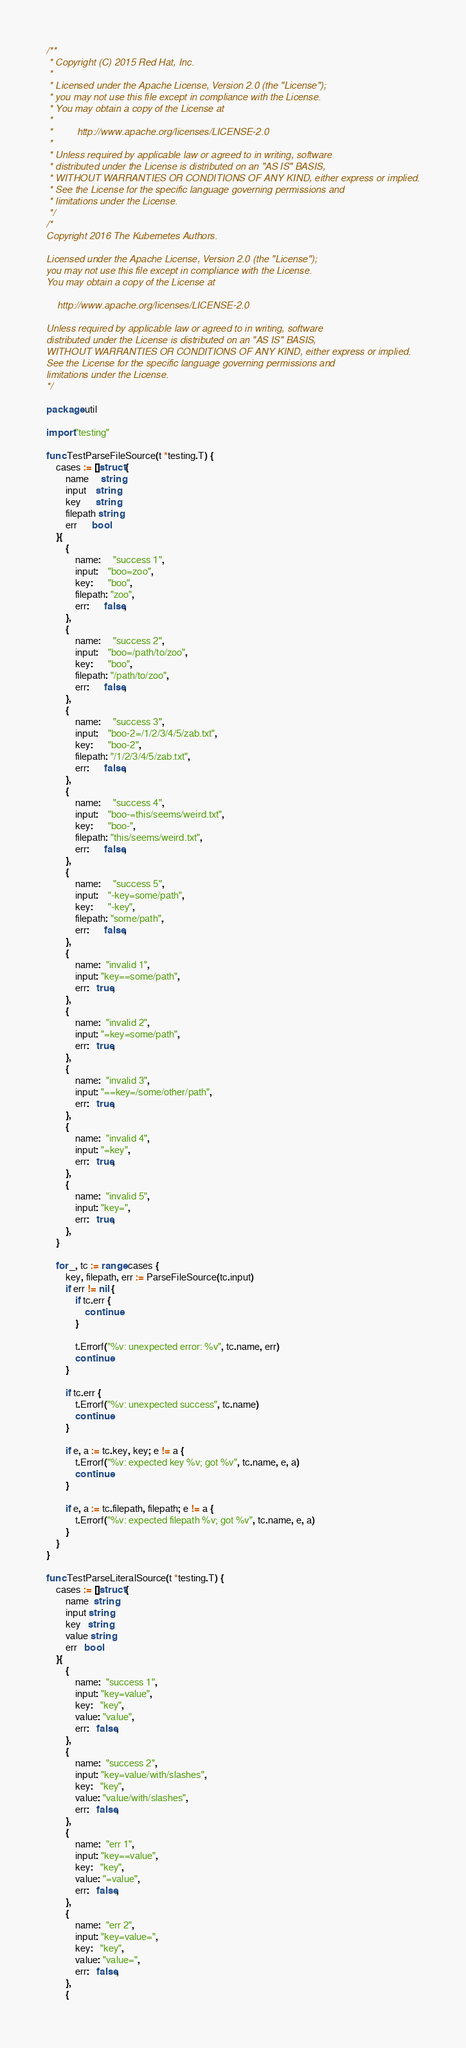Convert code to text. <code><loc_0><loc_0><loc_500><loc_500><_Go_>/**
 * Copyright (C) 2015 Red Hat, Inc.
 *
 * Licensed under the Apache License, Version 2.0 (the "License");
 * you may not use this file except in compliance with the License.
 * You may obtain a copy of the License at
 *
 *         http://www.apache.org/licenses/LICENSE-2.0
 *
 * Unless required by applicable law or agreed to in writing, software
 * distributed under the License is distributed on an "AS IS" BASIS,
 * WITHOUT WARRANTIES OR CONDITIONS OF ANY KIND, either express or implied.
 * See the License for the specific language governing permissions and
 * limitations under the License.
 */
/*
Copyright 2016 The Kubernetes Authors.

Licensed under the Apache License, Version 2.0 (the "License");
you may not use this file except in compliance with the License.
You may obtain a copy of the License at

    http://www.apache.org/licenses/LICENSE-2.0

Unless required by applicable law or agreed to in writing, software
distributed under the License is distributed on an "AS IS" BASIS,
WITHOUT WARRANTIES OR CONDITIONS OF ANY KIND, either express or implied.
See the License for the specific language governing permissions and
limitations under the License.
*/

package util

import "testing"

func TestParseFileSource(t *testing.T) {
	cases := []struct {
		name     string
		input    string
		key      string
		filepath string
		err      bool
	}{
		{
			name:     "success 1",
			input:    "boo=zoo",
			key:      "boo",
			filepath: "zoo",
			err:      false,
		},
		{
			name:     "success 2",
			input:    "boo=/path/to/zoo",
			key:      "boo",
			filepath: "/path/to/zoo",
			err:      false,
		},
		{
			name:     "success 3",
			input:    "boo-2=/1/2/3/4/5/zab.txt",
			key:      "boo-2",
			filepath: "/1/2/3/4/5/zab.txt",
			err:      false,
		},
		{
			name:     "success 4",
			input:    "boo-=this/seems/weird.txt",
			key:      "boo-",
			filepath: "this/seems/weird.txt",
			err:      false,
		},
		{
			name:     "success 5",
			input:    "-key=some/path",
			key:      "-key",
			filepath: "some/path",
			err:      false,
		},
		{
			name:  "invalid 1",
			input: "key==some/path",
			err:   true,
		},
		{
			name:  "invalid 2",
			input: "=key=some/path",
			err:   true,
		},
		{
			name:  "invalid 3",
			input: "==key=/some/other/path",
			err:   true,
		},
		{
			name:  "invalid 4",
			input: "=key",
			err:   true,
		},
		{
			name:  "invalid 5",
			input: "key=",
			err:   true,
		},
	}

	for _, tc := range cases {
		key, filepath, err := ParseFileSource(tc.input)
		if err != nil {
			if tc.err {
				continue
			}

			t.Errorf("%v: unexpected error: %v", tc.name, err)
			continue
		}

		if tc.err {
			t.Errorf("%v: unexpected success", tc.name)
			continue
		}

		if e, a := tc.key, key; e != a {
			t.Errorf("%v: expected key %v; got %v", tc.name, e, a)
			continue
		}

		if e, a := tc.filepath, filepath; e != a {
			t.Errorf("%v: expected filepath %v; got %v", tc.name, e, a)
		}
	}
}

func TestParseLiteralSource(t *testing.T) {
	cases := []struct {
		name  string
		input string
		key   string
		value string
		err   bool
	}{
		{
			name:  "success 1",
			input: "key=value",
			key:   "key",
			value: "value",
			err:   false,
		},
		{
			name:  "success 2",
			input: "key=value/with/slashes",
			key:   "key",
			value: "value/with/slashes",
			err:   false,
		},
		{
			name:  "err 1",
			input: "key==value",
			key:   "key",
			value: "=value",
			err:   false,
		},
		{
			name:  "err 2",
			input: "key=value=",
			key:   "key",
			value: "value=",
			err:   false,
		},
		{</code> 